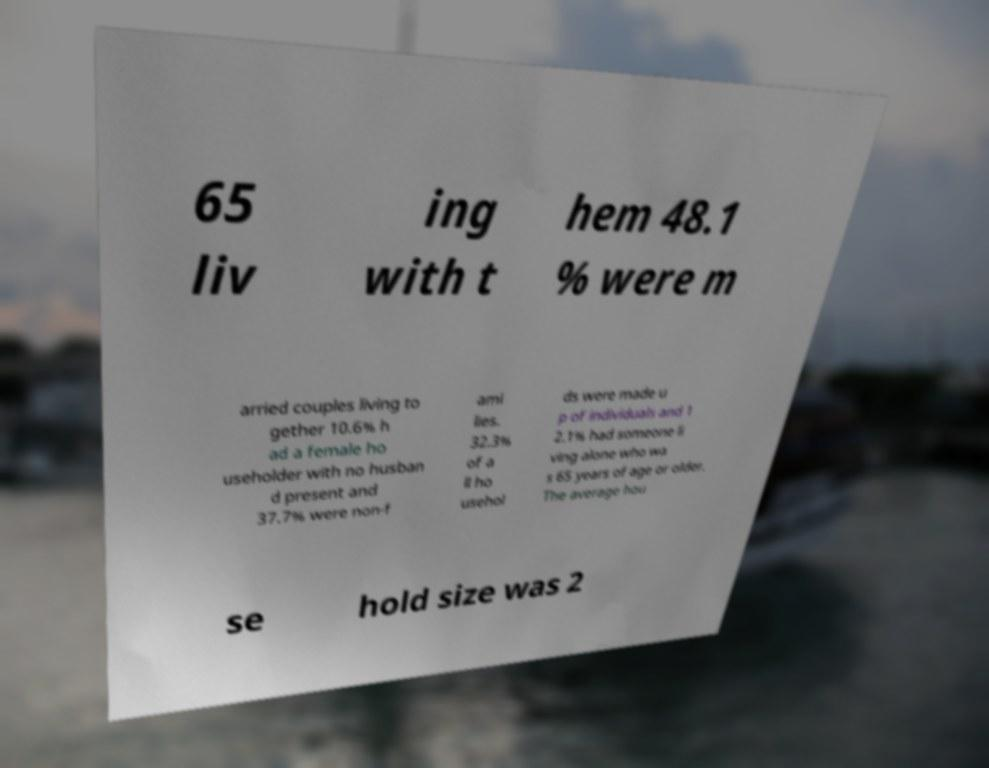There's text embedded in this image that I need extracted. Can you transcribe it verbatim? 65 liv ing with t hem 48.1 % were m arried couples living to gether 10.6% h ad a female ho useholder with no husban d present and 37.7% were non-f ami lies. 32.3% of a ll ho usehol ds were made u p of individuals and 1 2.1% had someone li ving alone who wa s 65 years of age or older. The average hou se hold size was 2 